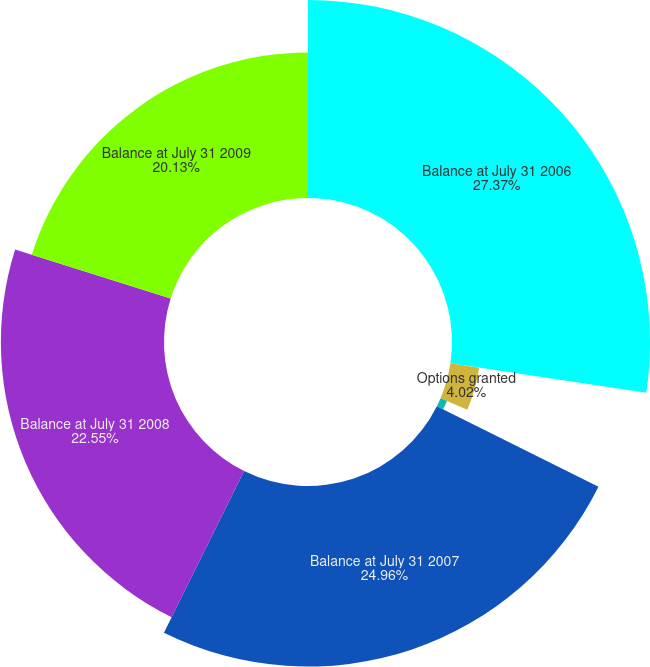<chart> <loc_0><loc_0><loc_500><loc_500><pie_chart><fcel>Balance at July 31 2006<fcel>Options granted<fcel>Options canceled or expired<fcel>Balance at July 31 2007<fcel>Balance at July 31 2008<fcel>Balance at July 31 2009<nl><fcel>27.37%<fcel>4.02%<fcel>0.97%<fcel>24.96%<fcel>22.55%<fcel>20.13%<nl></chart> 